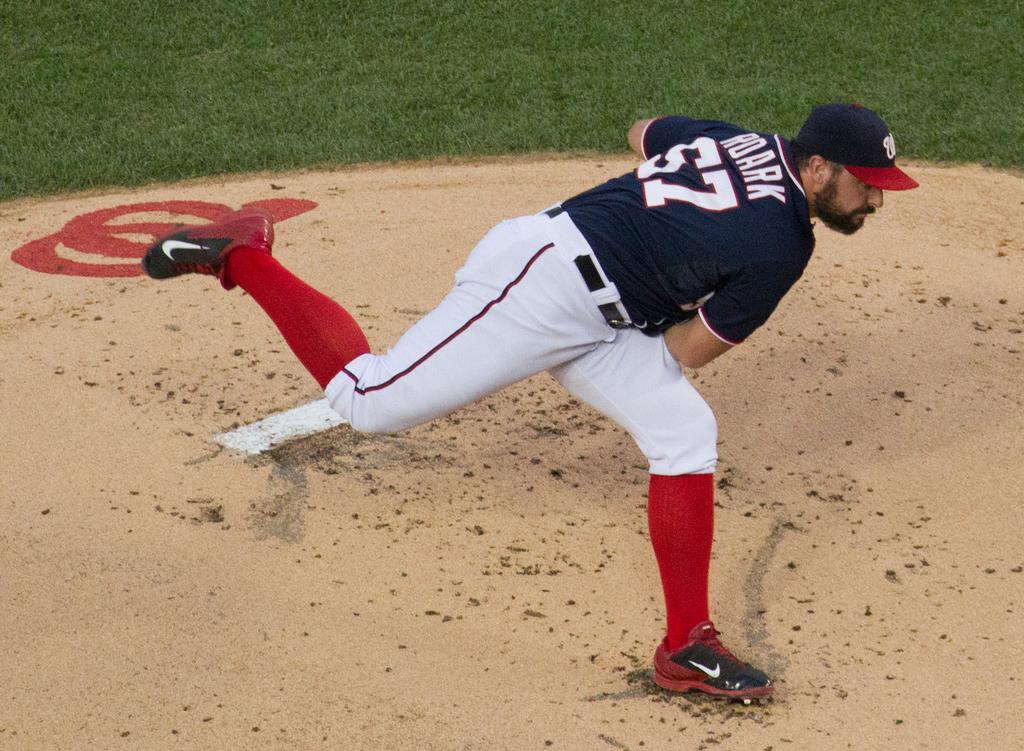<image>
Provide a brief description of the given image. Player number 57 is pitching the ball from the mound. 